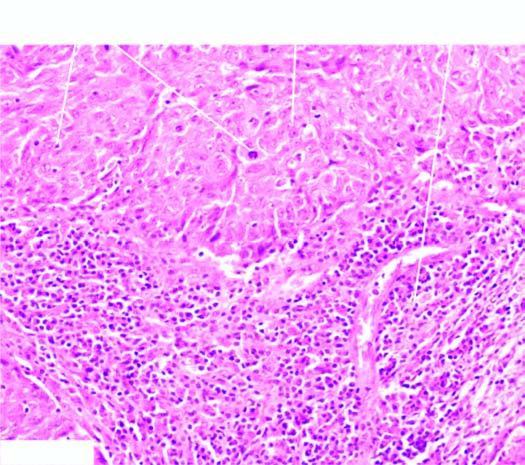does continuous involvement of the rectum and colon without any uninvolved show two characteristic features-large tumour cells forming syncytial arrangement and stroma infiltrated richly with lymphocytes?
Answer the question using a single word or phrase. No 